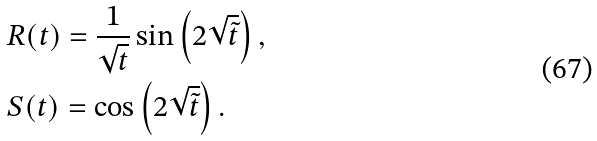Convert formula to latex. <formula><loc_0><loc_0><loc_500><loc_500>& R ( t ) = \frac { 1 } { \sqrt { t } } \sin \left ( 2 \sqrt { \tilde { t } } \right ) , \\ & S ( t ) = \cos \left ( 2 \sqrt { \tilde { t } } \right ) .</formula> 